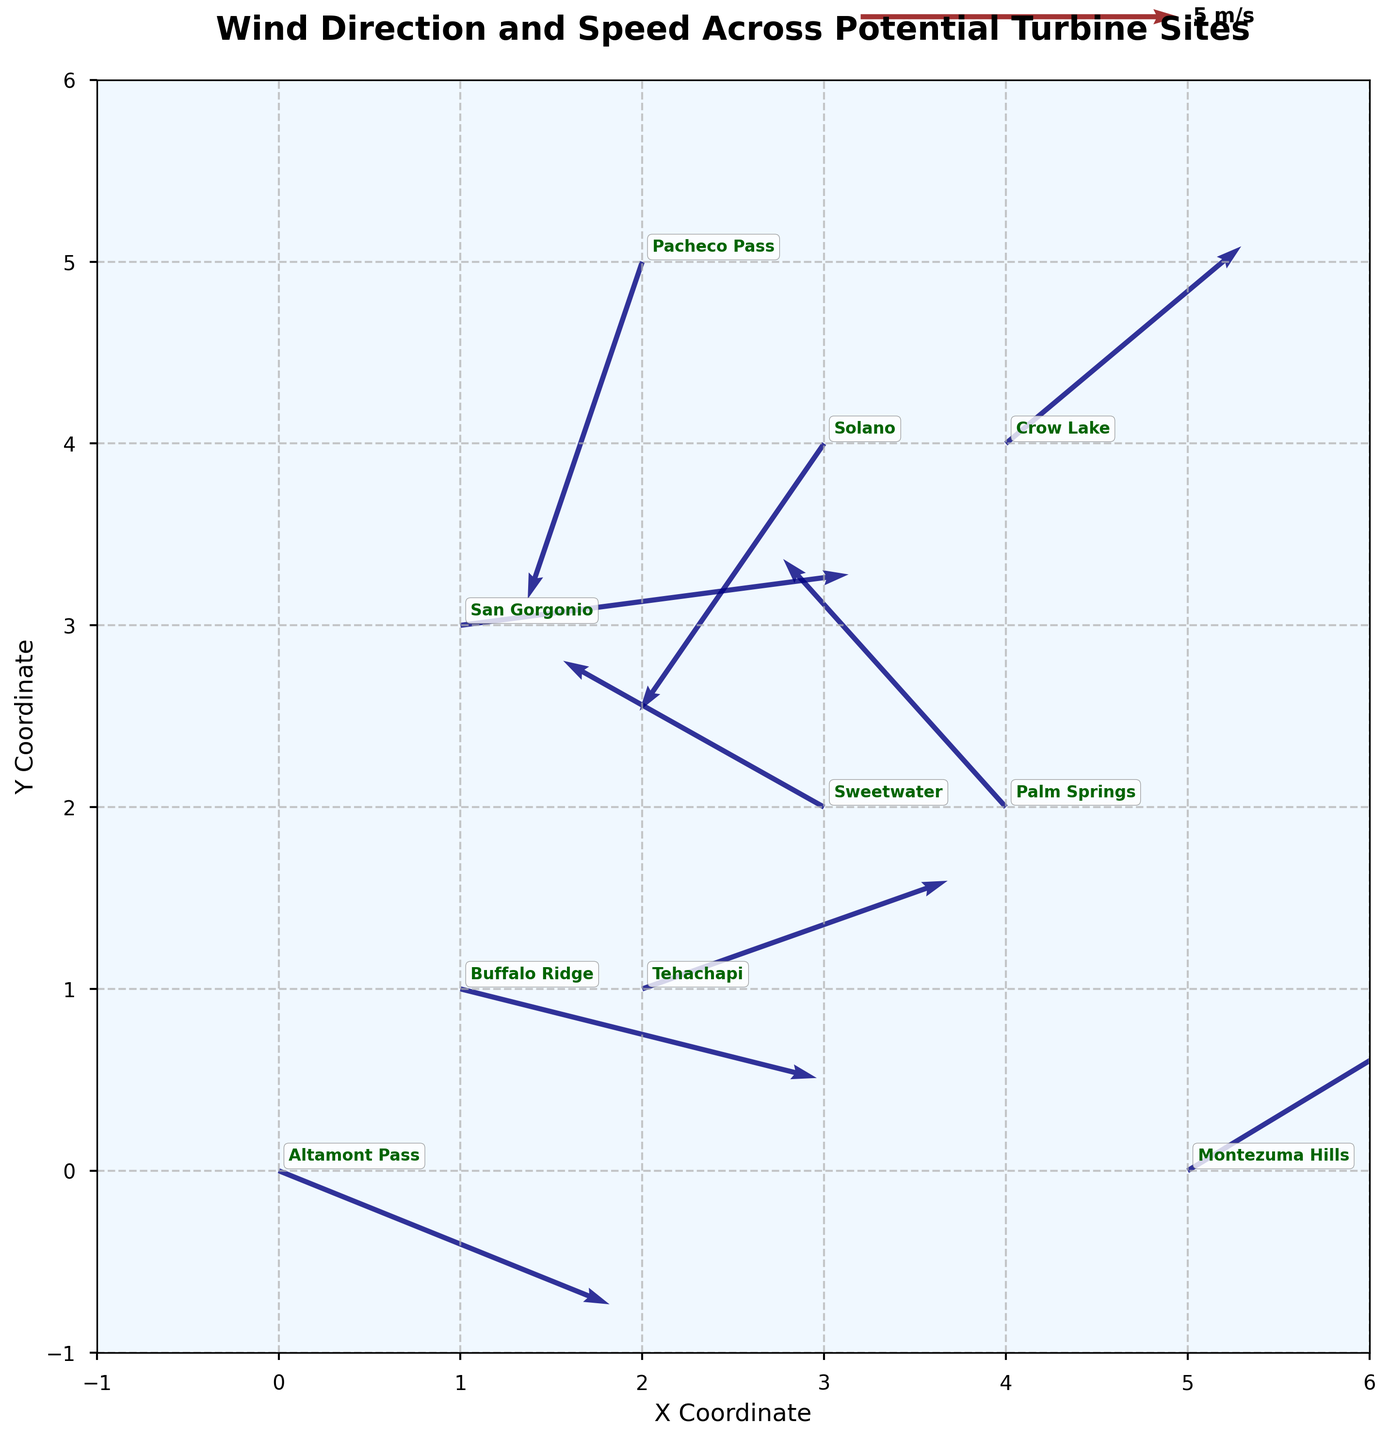How is the wind speed indicated in the plot? The wind speed is indicated by the length of the arrows. Longer arrows represent higher wind speeds, while shorter arrows represent lower wind speeds. Additionally, the quiver key shows that the length of a certain vector corresponds to a wind speed of 5 m/s.
Answer: By the length of the arrows Which site has the most southerly wind direction? To identify the site with the most southerly wind direction, look for the arrow pointing the closest to the south (downward on the plot). The site at (2, 5) has a vector pointing the most prominently downwards. According to the annotations, this site is Pacheco Pass.
Answer: Pacheco Pass What is the wind speed at the Montezuma Hills site? The Montezuma Hills site is located at coordinates (5, 0). The vector at this location has a magnitude that can be estimated using the quiver scale. Given the vector's length relative to the quiver key, the wind speed is approximately 5 m/s.
Answer: Approximately 5 m/s How does the wind direction at Palm Springs compare to that at Sweetwater? At Palm Springs (4, 2), the wind vector points in the north-western direction. At Sweetwater (3, 2), the wind vector points in the south-western direction. Hence, Palm Springs has wind blowing towards the northwest, while Sweetwater has wind blowing towards the southwest.
Answer: Palm Springs: northwest, Sweetwater: southwest Which site has the highest absolute wind speed, and what is it? To find absolute wind speed, calculate the magnitudes of the vectors √(u^2 + v^2). Checking all sites:
- Altamont Pass: √(5.2^2 + (-2.1)^2) ≈ 5.54 m/s
- Tehachapi: √(4.8^2 + 1.7^2) ≈ 5.12 m/s
- Palm Springs: √((-3.5)^2 + 3.9^2) ≈ 5.20 m/s
- San Gorgonio: √(6.1^2 + 0.8^2) ≈ 6.15 m/s
- Solano: √((-2.9)^2 + (-4.2)^2) ≈ 5.10 m/s
- Montezuma Hills: √(4.3^2 + 2.6^2) ≈ 5.05 m/s
- Pacheco Pass: √((-1.8)^2 + (-5.3)^2) ≈ 5.60 m/s
- Crow Lake: √(3.7^2 + 3.1^2) ≈ 4.85 m/s
- Buffalo Ridge: √(5.6^2 + (-1.4)^2) ≈ 5.75 m/s
- Sweetwater: √((-4.1)^2 + 2.3^2) ≈ 4.72 m/s
The highest absolute wind speed is at San Gorgonio, approximately 6.15 m/s.
Answer: San Gorgonio, approximately 6.15 m/s What wind direction and speed can be observed at Buffalo Ridge? Buffalo Ridge is located at (1, 1) in the plot. The wind vector points to the southeast with coordinates (5.6, -1.4). Using the quiver key, the magnitude can be calculated: √(5.6^2 + (-1.4)^2) ≈ 5.75 m/s.
Answer: Southeast, approximately 5.75 m/s Describe the general wind pattern observed in the southeastern quadrant of the plot. In the southeastern quadrant (both x and y coordinates range approximately between 3 and 5), the wind vectors mostly point towards the northeast, indicating a general wind pattern blowing in that direction. This suggests a predominant northeastern wind in that area.
Answer: Predominantly northeast Which site has the least wind speed and what is it? Check the magnitudes of all vectors to find the smallest:
- Altamont Pass: √(5.2^2 + (-2.1)^2) ≈ 5.54 m/s
- Tehachapi: √(4.8^2 + 1.7^2) ≈ 5.12 m/s
- Palm Springs: √((-3.5)^2 + 3.9^2) ≈ 5.20 m/s
- San Gorgonio: √(6.1^2 + 0.8^2) ≈ 6.15 m/s
- Solano: √((-2.9)^2 + (-4.2)^2) ≈ 5.10 m/s
- Montezuma Hills: √(4.3^2 + 2.6^2) ≈ 5.05 m/s
- Pacheco Pass: √((-1.8)^2 + (-5.3)^2) ≈ 5.60 m/s
- Crow Lake: √(3.7^2 + 3.1^2) ≈ 4.85 m/s
- Buffalo Ridge: √(5.6^2 + (-1.4)^2) ≈ 5.75 m/s
- Sweetwater: √((-4.1)^2 + 2.3^2) ≈ 4.72 m/s
The least wind speed is at Sweetwater, approximately 4.72 m/s.
Answer: Sweetwater, approximately 4.72 m/s Is there any site with wind blowing almost directly towards the north? To determine this, look for vectors pointing almost straight up (north direction). The site at (4, 4), Crow Lake, has a vector pointing predominantly upwards.
Answer: Crow Lake 